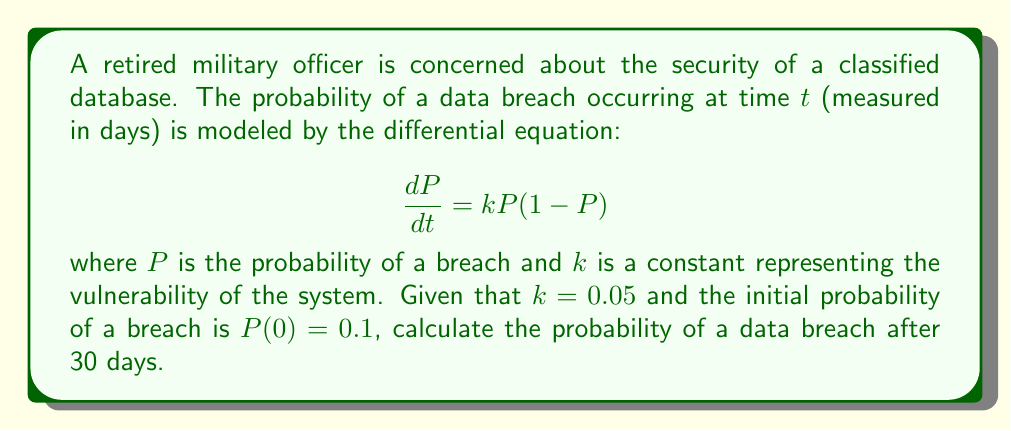What is the answer to this math problem? To solve this problem, we need to follow these steps:

1) First, we recognize this as a logistic differential equation.

2) The general solution for this type of equation is:

   $$P(t) = \frac{1}{1 + Ce^{-kt}}$$

   where $C$ is a constant we need to determine.

3) We use the initial condition $P(0) = 0.1$ to find $C$:

   $$0.1 = \frac{1}{1 + C}$$

   $$1 + C = \frac{1}{0.1} = 10$$

   $$C = 9$$

4) Now we have our specific solution:

   $$P(t) = \frac{1}{1 + 9e^{-0.05t}}$$

5) To find the probability after 30 days, we substitute $t = 30$:

   $$P(30) = \frac{1}{1 + 9e^{-0.05(30)}}$$

6) Simplifying:

   $$P(30) = \frac{1}{1 + 9e^{-1.5}}$$

   $$P(30) = \frac{1}{1 + 9(0.2231)}$$

   $$P(30) = \frac{1}{3.0079}$$

   $$P(30) \approx 0.3325$$

Therefore, the probability of a data breach after 30 days is approximately 0.3325 or 33.25%.
Answer: $P(30) \approx 0.3325$ or $33.25\%$ 